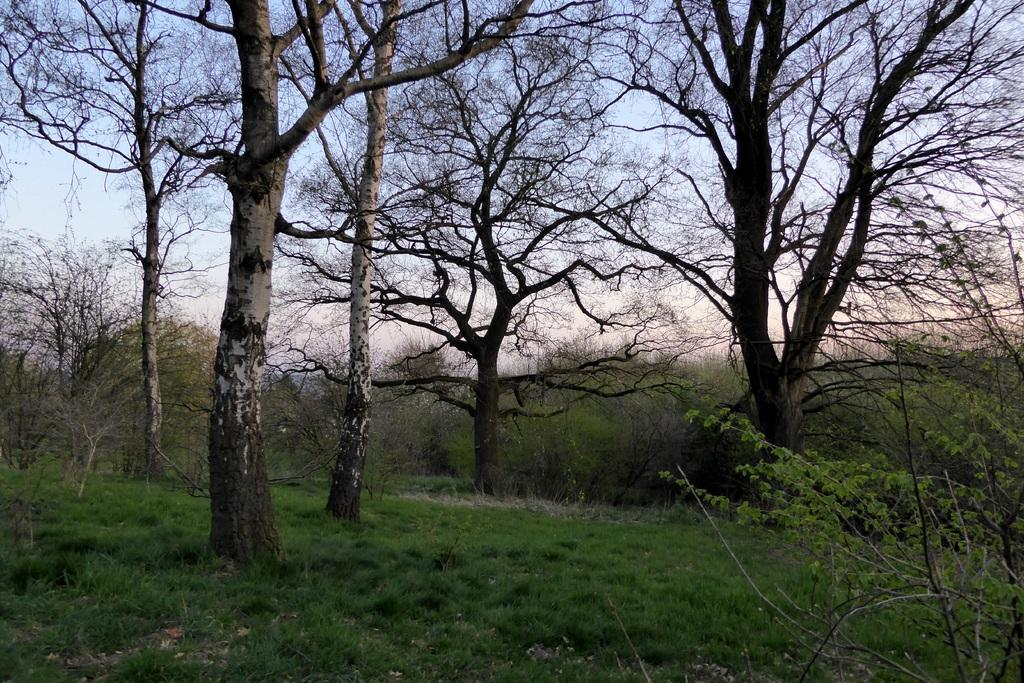What type of vegetation can be seen in the image? There are trees and plants in the image. What covers the ground in the image? There is grass on the ground in the image. What part of the natural environment is visible in the image? The sky is visible in the image. How many leaves are on the skin of the person in the image? There is no person present in the image, and therefore no skin or leaves can be observed. 